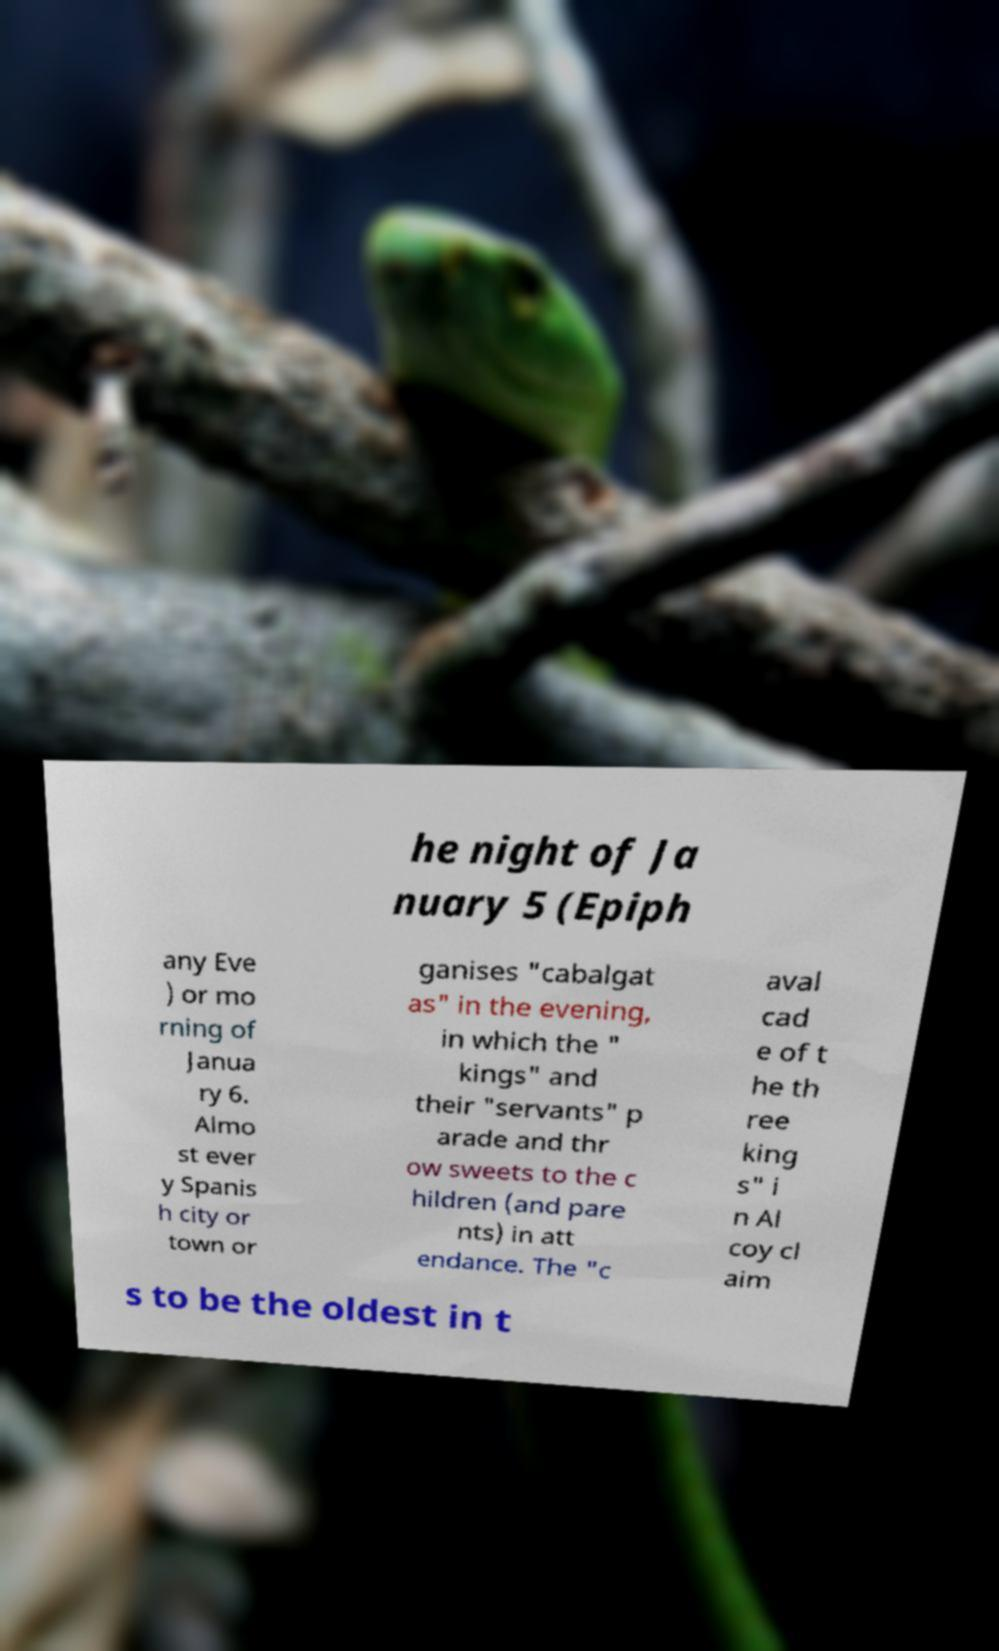For documentation purposes, I need the text within this image transcribed. Could you provide that? he night of Ja nuary 5 (Epiph any Eve ) or mo rning of Janua ry 6. Almo st ever y Spanis h city or town or ganises "cabalgat as" in the evening, in which the " kings" and their "servants" p arade and thr ow sweets to the c hildren (and pare nts) in att endance. The "c aval cad e of t he th ree king s" i n Al coy cl aim s to be the oldest in t 